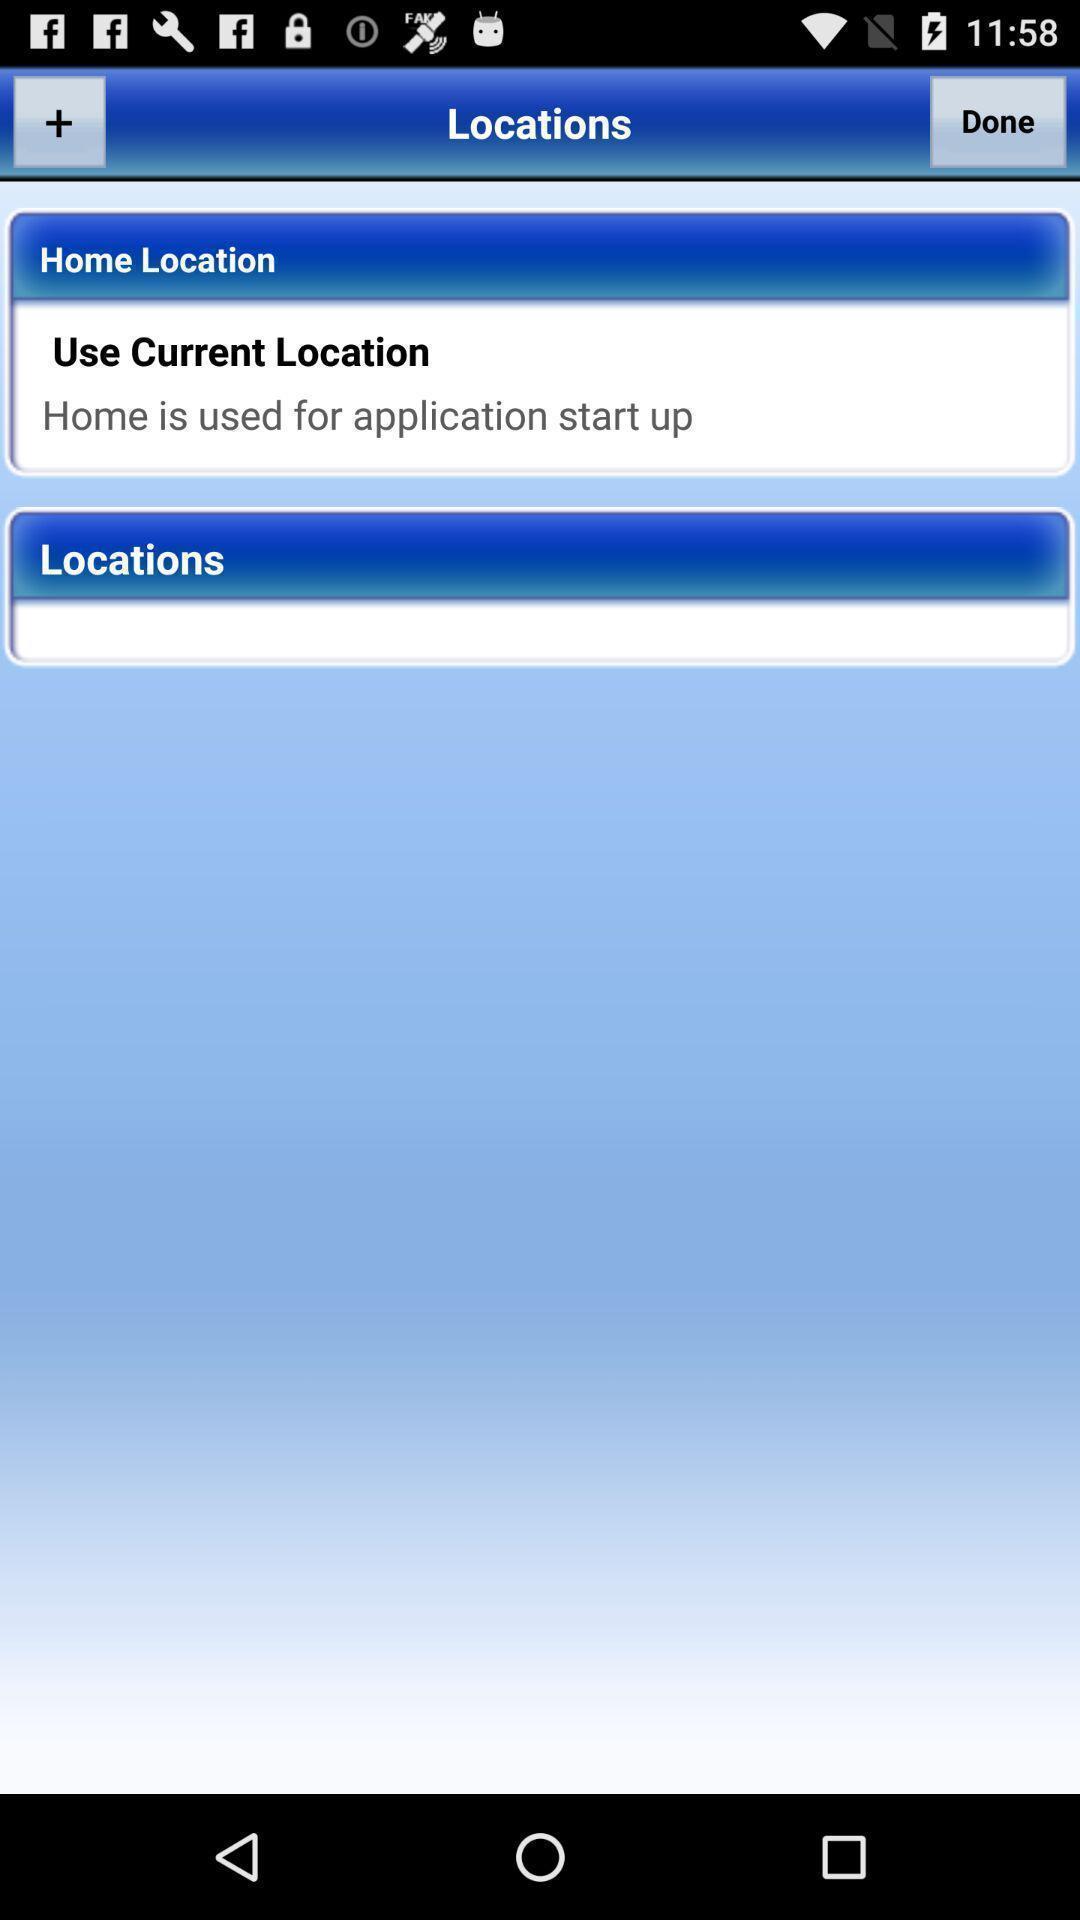Explain the elements present in this screenshot. Screen showing locations. 